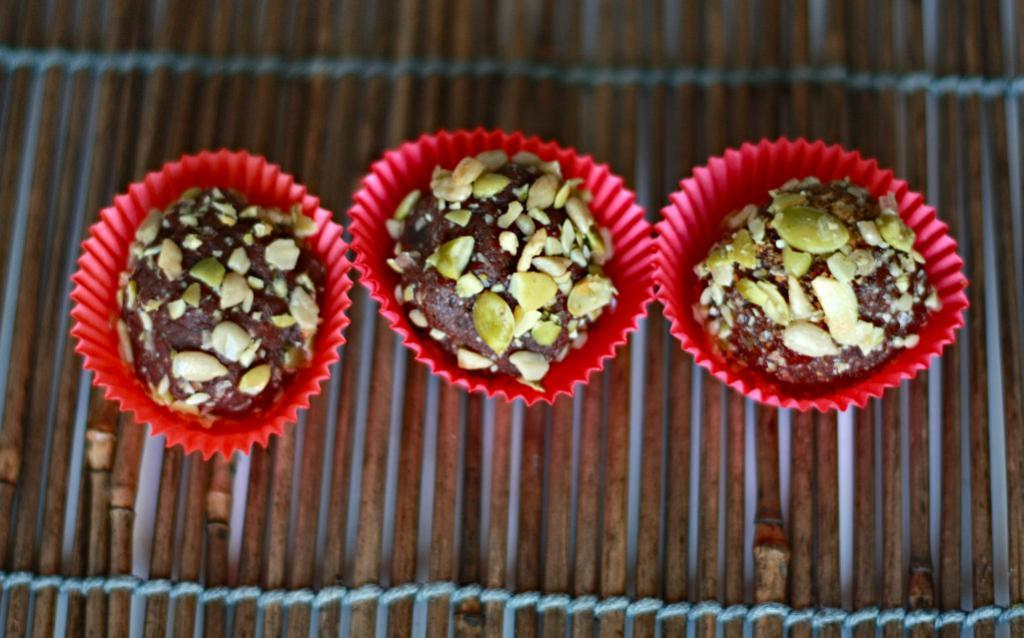What type of dessert can be seen in the image? There are cupcakes in the image. What is on top of the cupcakes? The cupcakes are topped with nuts. Where are the cupcakes located? The cupcakes are placed on a surface. How many kittens are playing with the locket on the cupcakes in the image? There are no kittens or lockets present in the image; it features cupcakes topped with nuts. 